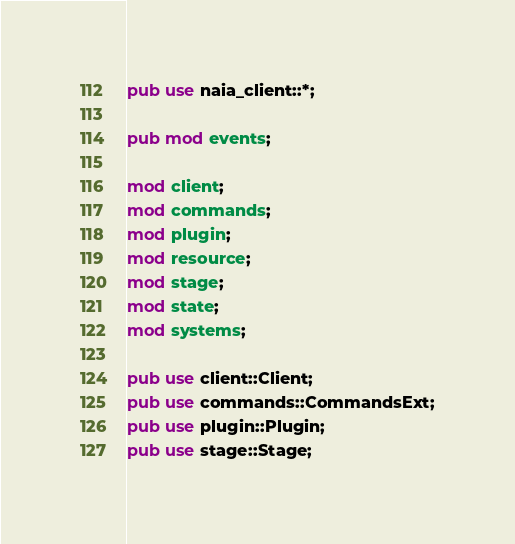<code> <loc_0><loc_0><loc_500><loc_500><_Rust_>pub use naia_client::*;

pub mod events;

mod client;
mod commands;
mod plugin;
mod resource;
mod stage;
mod state;
mod systems;

pub use client::Client;
pub use commands::CommandsExt;
pub use plugin::Plugin;
pub use stage::Stage;
</code> 